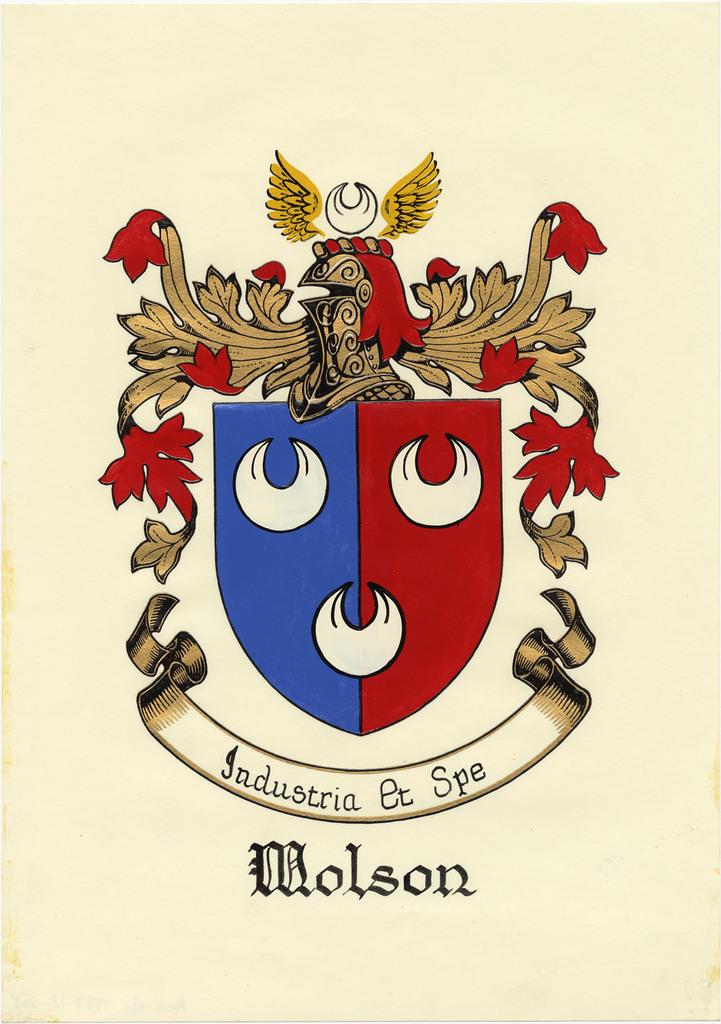What is the word at the bottom?
Offer a terse response. Molson. What is the last worn on the banner?
Offer a terse response. Spe. 